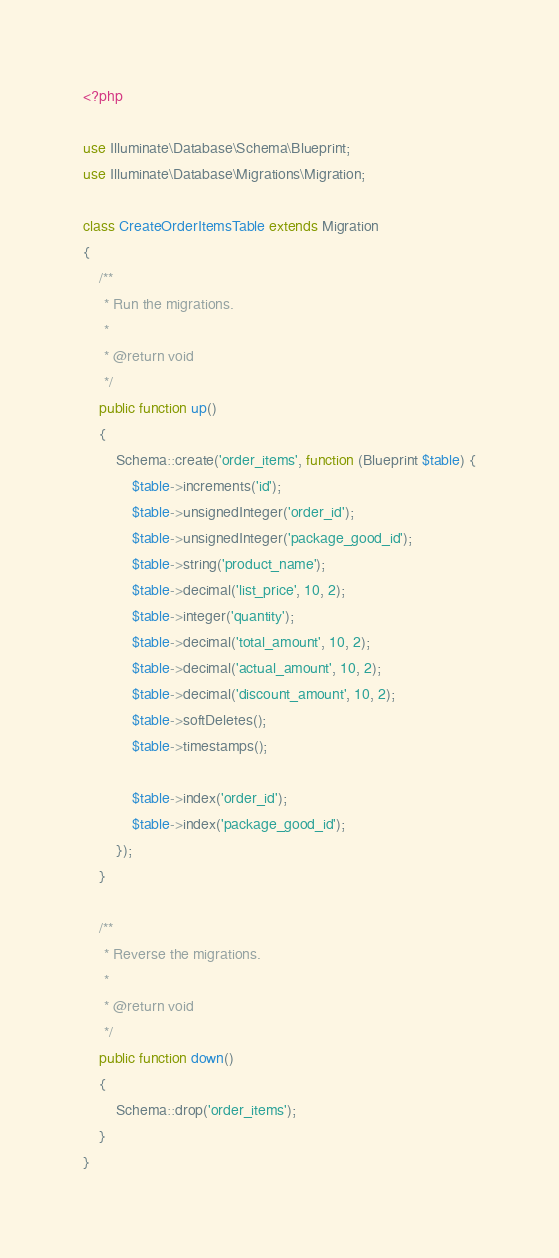<code> <loc_0><loc_0><loc_500><loc_500><_PHP_><?php

use Illuminate\Database\Schema\Blueprint;
use Illuminate\Database\Migrations\Migration;

class CreateOrderItemsTable extends Migration
{
    /**
     * Run the migrations.
     *
     * @return void
     */
    public function up()
    {
        Schema::create('order_items', function (Blueprint $table) {
            $table->increments('id');
            $table->unsignedInteger('order_id');
            $table->unsignedInteger('package_good_id');
            $table->string('product_name');
            $table->decimal('list_price', 10, 2);
            $table->integer('quantity');
            $table->decimal('total_amount', 10, 2);
            $table->decimal('actual_amount', 10, 2);
            $table->decimal('discount_amount', 10, 2);
            $table->softDeletes();
            $table->timestamps();

            $table->index('order_id');
            $table->index('package_good_id');
        });
    }

    /**
     * Reverse the migrations.
     *
     * @return void
     */
    public function down()
    {
        Schema::drop('order_items');
    }
}
</code> 